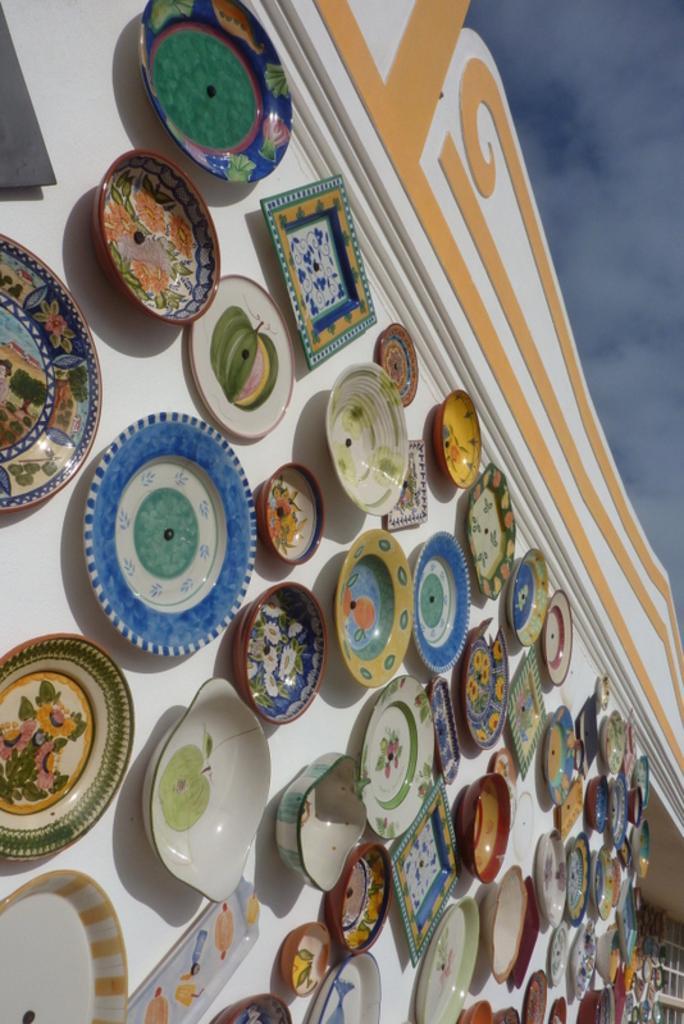How would you summarize this image in a sentence or two? In this image we can see bowls, plates, and trays on the wall. On the right side of the image we can see sky with clouds. 